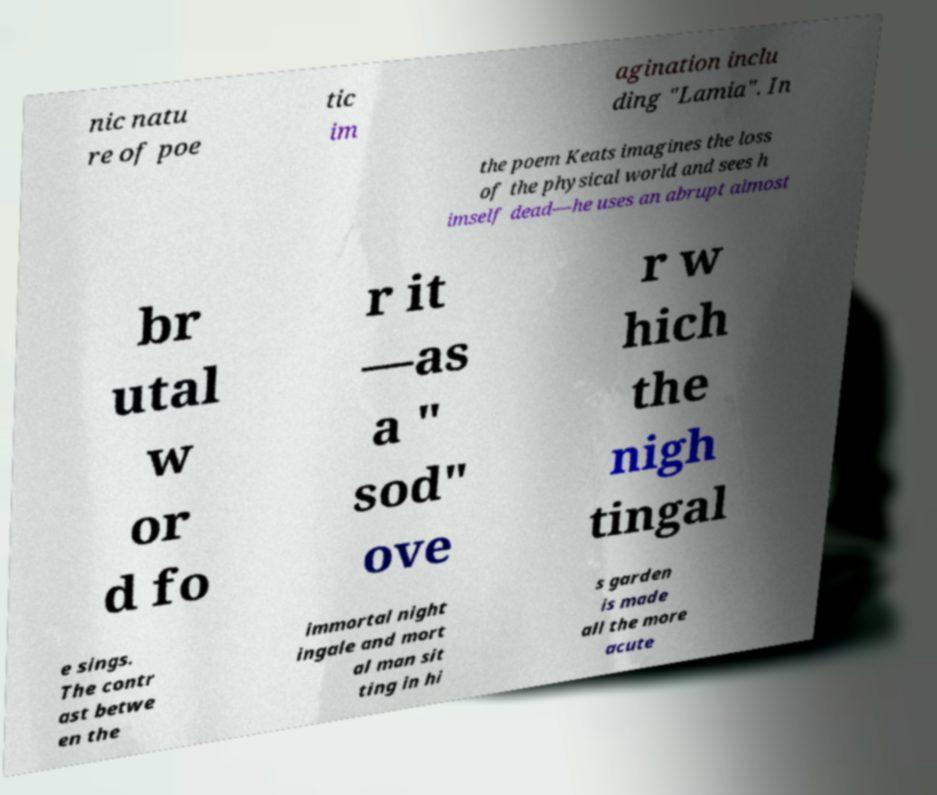Please read and relay the text visible in this image. What does it say? nic natu re of poe tic im agination inclu ding "Lamia". In the poem Keats imagines the loss of the physical world and sees h imself dead—he uses an abrupt almost br utal w or d fo r it —as a " sod" ove r w hich the nigh tingal e sings. The contr ast betwe en the immortal night ingale and mort al man sit ting in hi s garden is made all the more acute 